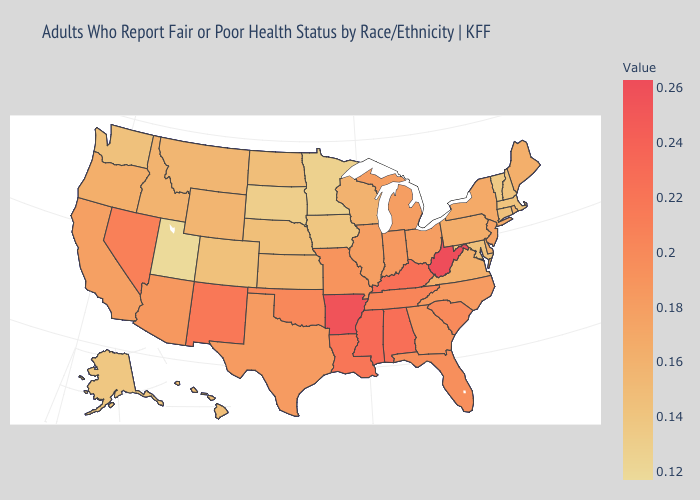Does Missouri have a lower value than Washington?
Answer briefly. No. Among the states that border Tennessee , does Georgia have the lowest value?
Short answer required. No. Does Michigan have a higher value than Oregon?
Give a very brief answer. Yes. Does Utah have the lowest value in the West?
Short answer required. Yes. 